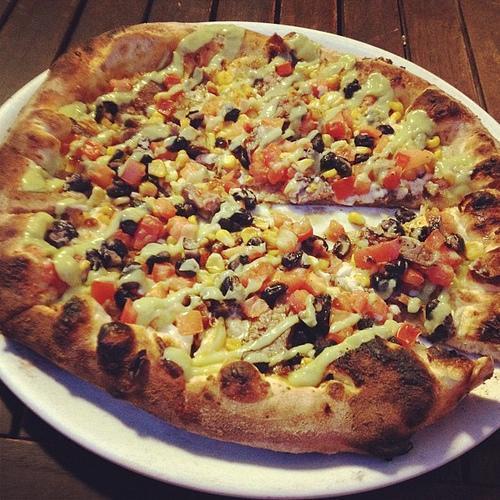How many pizzas are in the picture?
Give a very brief answer. 1. 